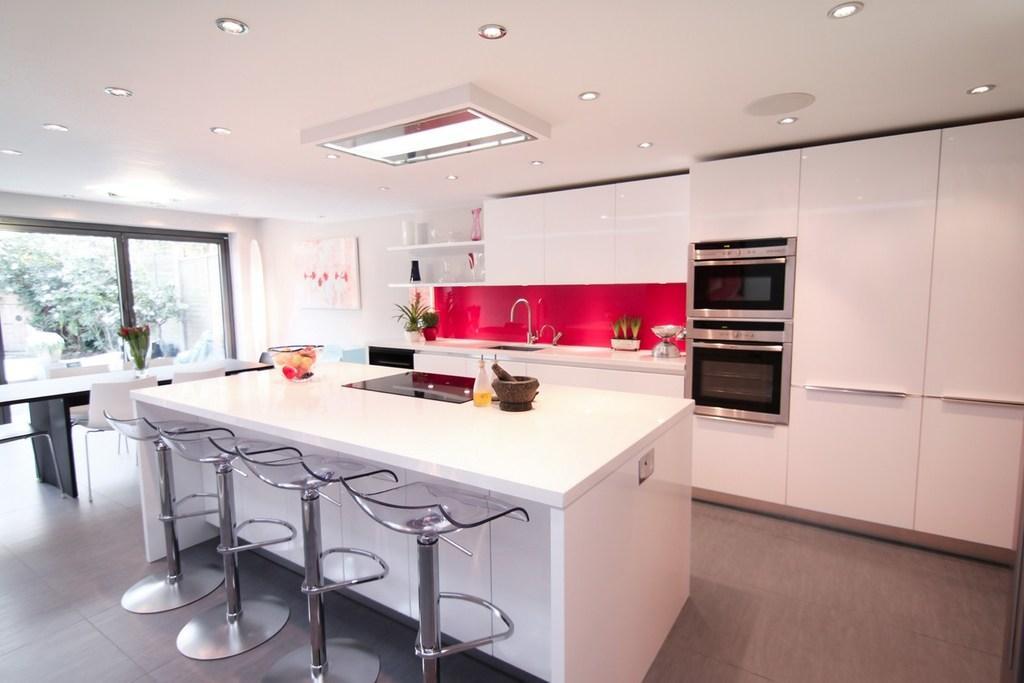Please provide a concise description of this image. In this image i can see a kitchen table with few chairs and a countertop with sink and a tap. In the background i can see a Owen, a window and trees. 